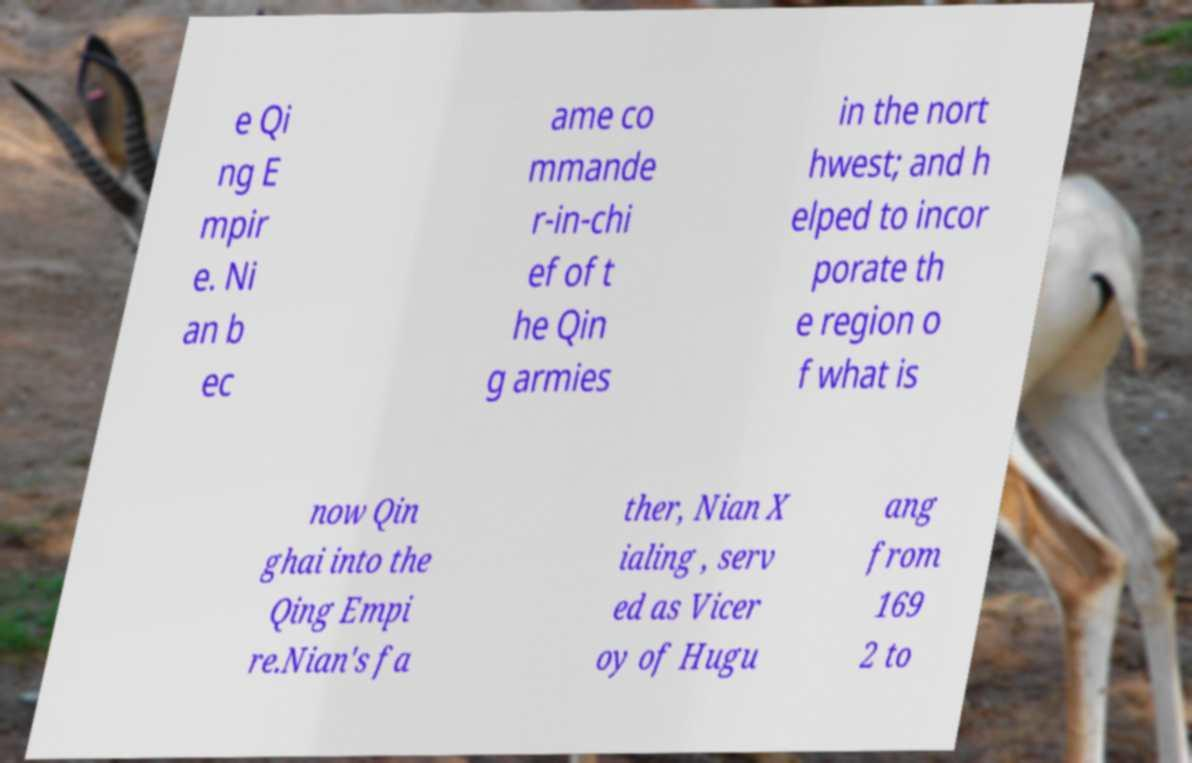Can you read and provide the text displayed in the image?This photo seems to have some interesting text. Can you extract and type it out for me? e Qi ng E mpir e. Ni an b ec ame co mmande r-in-chi ef of t he Qin g armies in the nort hwest; and h elped to incor porate th e region o f what is now Qin ghai into the Qing Empi re.Nian's fa ther, Nian X ialing , serv ed as Vicer oy of Hugu ang from 169 2 to 